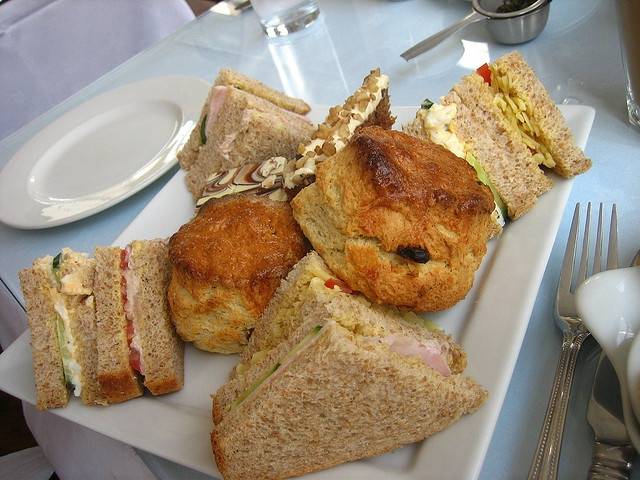Describe the objects in this image and their specific colors. I can see dining table in darkgray, brown, tan, lightgray, and gray tones, sandwich in lightyellow, gray, tan, and olive tones, sandwich in lightyellow, tan, gray, olive, and maroon tones, sandwich in lightyellow and tan tones, and sandwich in lightyellow, tan, and gray tones in this image. 